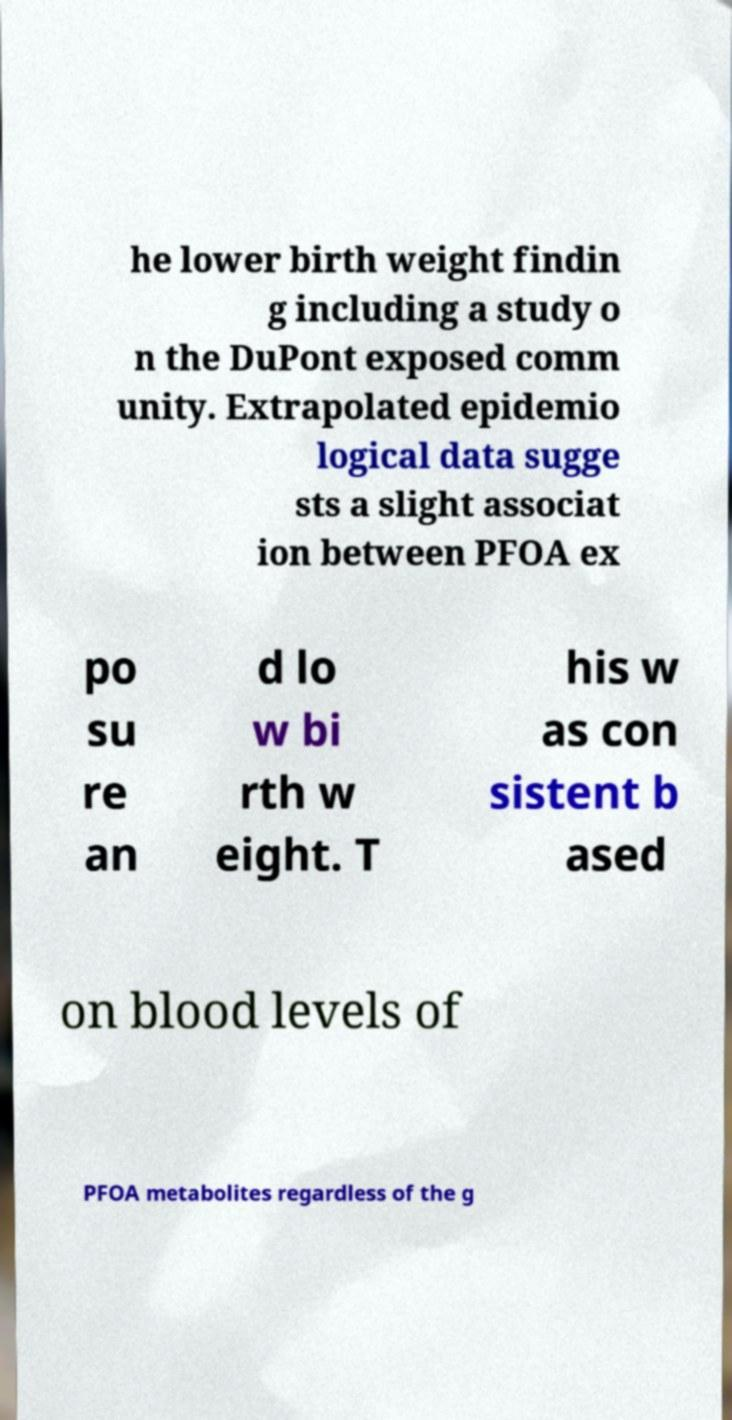Please read and relay the text visible in this image. What does it say? he lower birth weight findin g including a study o n the DuPont exposed comm unity. Extrapolated epidemio logical data sugge sts a slight associat ion between PFOA ex po su re an d lo w bi rth w eight. T his w as con sistent b ased on blood levels of PFOA metabolites regardless of the g 